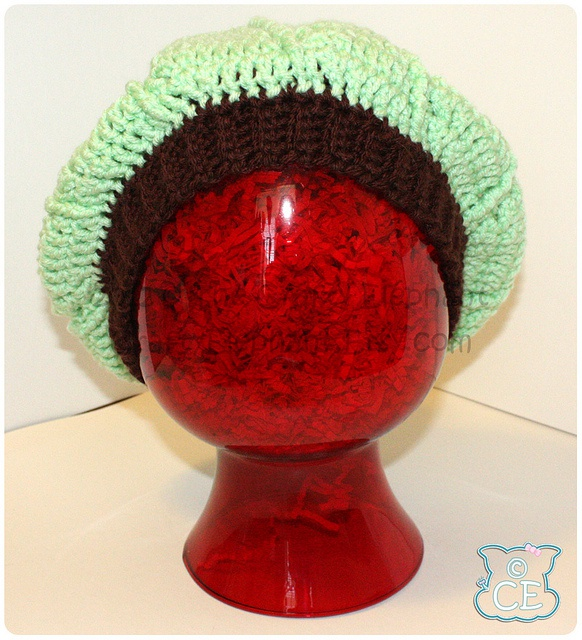Describe the objects in this image and their specific colors. I can see a vase in white, maroon, and brown tones in this image. 